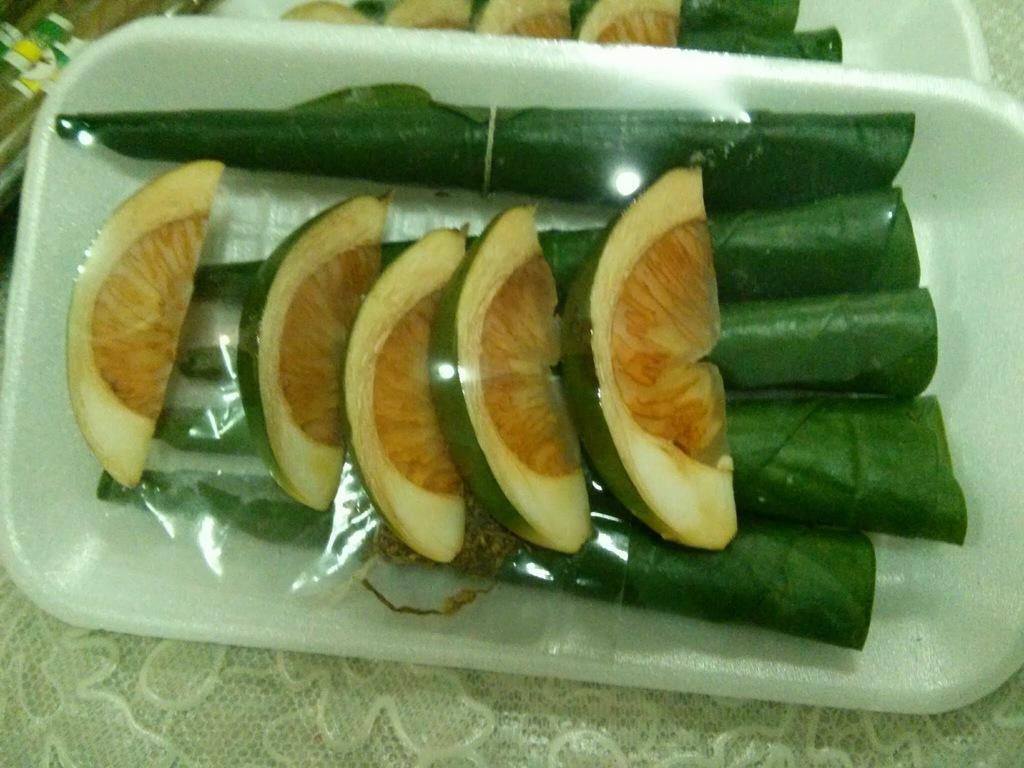In one or two sentences, can you explain what this image depicts? Here we can see a fruit slices on the rolled leaves in a plate on a platform. In the background there are some objects,fruits slices on the rolled leaves in a plate on a platform. 